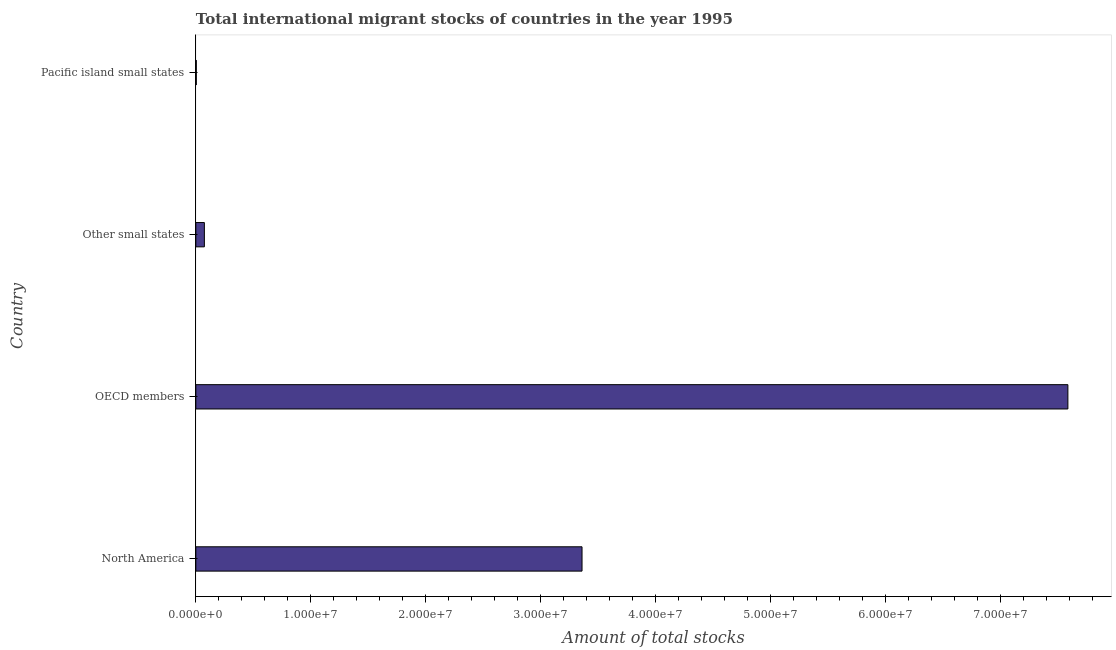Does the graph contain any zero values?
Ensure brevity in your answer.  No. Does the graph contain grids?
Your response must be concise. No. What is the title of the graph?
Your answer should be very brief. Total international migrant stocks of countries in the year 1995. What is the label or title of the X-axis?
Provide a succinct answer. Amount of total stocks. What is the label or title of the Y-axis?
Give a very brief answer. Country. What is the total number of international migrant stock in Pacific island small states?
Offer a very short reply. 4.04e+04. Across all countries, what is the maximum total number of international migrant stock?
Offer a very short reply. 7.58e+07. Across all countries, what is the minimum total number of international migrant stock?
Keep it short and to the point. 4.04e+04. In which country was the total number of international migrant stock maximum?
Provide a short and direct response. OECD members. In which country was the total number of international migrant stock minimum?
Ensure brevity in your answer.  Pacific island small states. What is the sum of the total number of international migrant stock?
Your answer should be very brief. 1.10e+08. What is the difference between the total number of international migrant stock in North America and OECD members?
Your answer should be compact. -4.23e+07. What is the average total number of international migrant stock per country?
Give a very brief answer. 2.76e+07. What is the median total number of international migrant stock?
Give a very brief answer. 1.72e+07. What is the ratio of the total number of international migrant stock in North America to that in Other small states?
Your answer should be very brief. 45.21. Is the total number of international migrant stock in Other small states less than that in Pacific island small states?
Your answer should be compact. No. What is the difference between the highest and the second highest total number of international migrant stock?
Your response must be concise. 4.23e+07. What is the difference between the highest and the lowest total number of international migrant stock?
Keep it short and to the point. 7.58e+07. In how many countries, is the total number of international migrant stock greater than the average total number of international migrant stock taken over all countries?
Your answer should be very brief. 2. Are all the bars in the graph horizontal?
Your answer should be very brief. Yes. Are the values on the major ticks of X-axis written in scientific E-notation?
Offer a terse response. Yes. What is the Amount of total stocks in North America?
Your answer should be compact. 3.36e+07. What is the Amount of total stocks in OECD members?
Offer a terse response. 7.58e+07. What is the Amount of total stocks of Other small states?
Offer a very short reply. 7.43e+05. What is the Amount of total stocks of Pacific island small states?
Make the answer very short. 4.04e+04. What is the difference between the Amount of total stocks in North America and OECD members?
Keep it short and to the point. -4.23e+07. What is the difference between the Amount of total stocks in North America and Other small states?
Offer a terse response. 3.28e+07. What is the difference between the Amount of total stocks in North America and Pacific island small states?
Give a very brief answer. 3.35e+07. What is the difference between the Amount of total stocks in OECD members and Other small states?
Provide a short and direct response. 7.51e+07. What is the difference between the Amount of total stocks in OECD members and Pacific island small states?
Make the answer very short. 7.58e+07. What is the difference between the Amount of total stocks in Other small states and Pacific island small states?
Provide a succinct answer. 7.03e+05. What is the ratio of the Amount of total stocks in North America to that in OECD members?
Your answer should be compact. 0.44. What is the ratio of the Amount of total stocks in North America to that in Other small states?
Offer a terse response. 45.21. What is the ratio of the Amount of total stocks in North America to that in Pacific island small states?
Offer a terse response. 832.01. What is the ratio of the Amount of total stocks in OECD members to that in Other small states?
Provide a succinct answer. 102.08. What is the ratio of the Amount of total stocks in OECD members to that in Pacific island small states?
Keep it short and to the point. 1878.72. What is the ratio of the Amount of total stocks in Other small states to that in Pacific island small states?
Your answer should be compact. 18.4. 